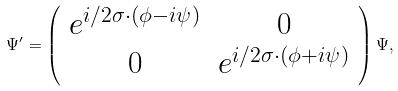<formula> <loc_0><loc_0><loc_500><loc_500>\Psi ^ { \prime } = \left ( \begin{array} { c c } e ^ { i / 2 \sigma \cdot ( \phi - i \psi ) } & 0 \\ 0 & e ^ { i / 2 \sigma \cdot ( \phi + i \psi ) } \end{array} \right ) \Psi ,</formula> 